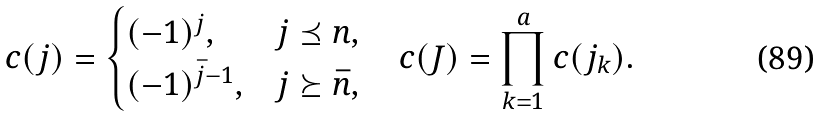<formula> <loc_0><loc_0><loc_500><loc_500>c ( j ) = \begin{cases} ( - 1 ) ^ { j } , & j \preceq n , \\ ( - 1 ) ^ { \bar { j } - 1 } , & j \succeq \bar { n } , \end{cases} \quad c ( J ) = \prod ^ { a } _ { k = 1 } c ( j _ { k } ) .</formula> 